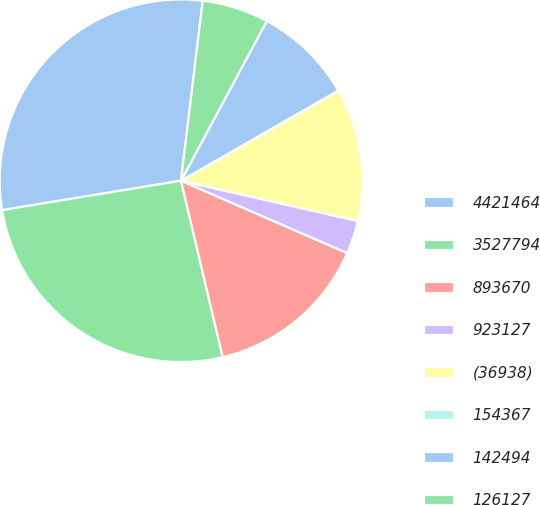<chart> <loc_0><loc_0><loc_500><loc_500><pie_chart><fcel>4421464<fcel>3527794<fcel>893670<fcel>923127<fcel>(36938)<fcel>154367<fcel>142494<fcel>126127<nl><fcel>29.51%<fcel>26.1%<fcel>14.77%<fcel>2.98%<fcel>11.82%<fcel>0.03%<fcel>8.87%<fcel>5.93%<nl></chart> 